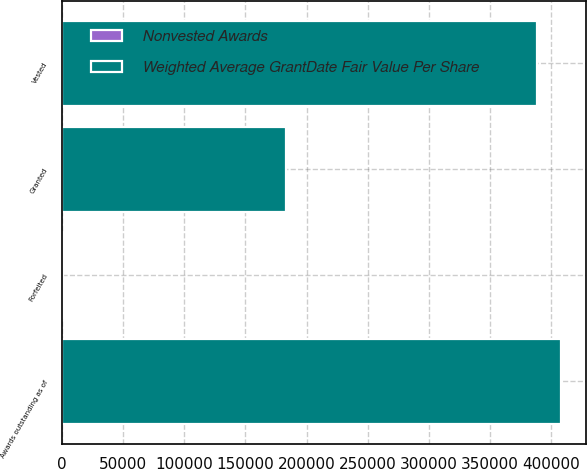<chart> <loc_0><loc_0><loc_500><loc_500><stacked_bar_chart><ecel><fcel>Awards outstanding as of<fcel>Granted<fcel>Vested<fcel>Forfeited<nl><fcel>Weighted Average GrantDate Fair Value Per Share<fcel>408425<fcel>183299<fcel>388561<fcel>703<nl><fcel>Nonvested Awards<fcel>66.23<fcel>88.97<fcel>38.77<fcel>48.57<nl></chart> 